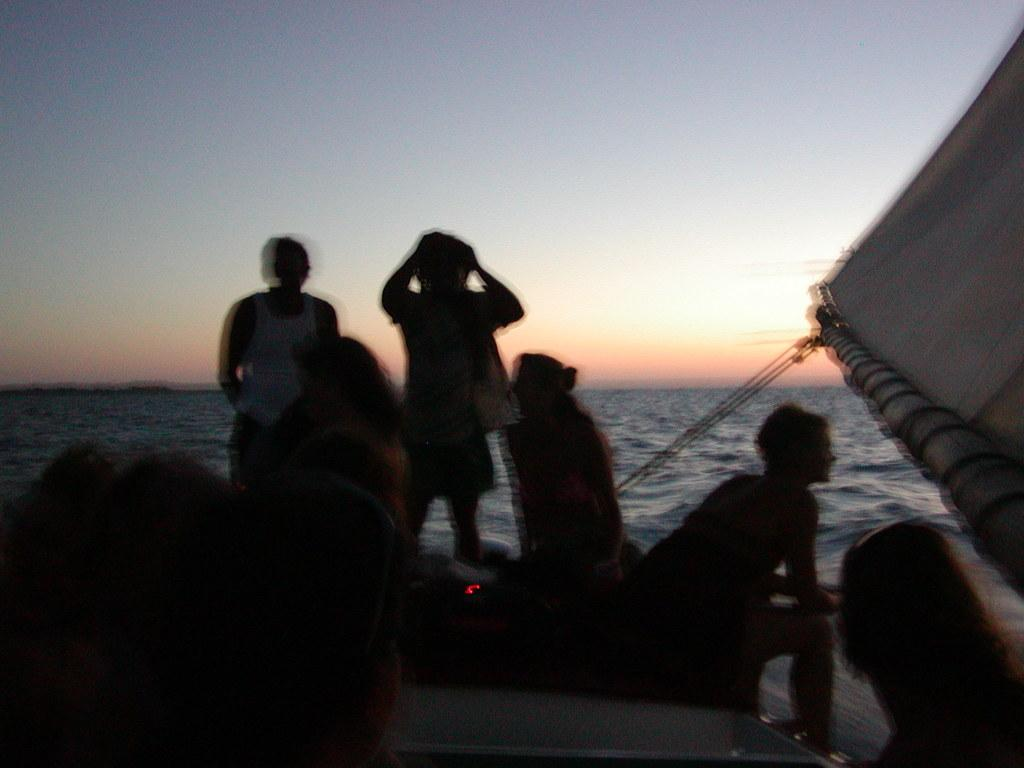How many people are in the image? There is a group of people in the image. What objects are present that might be used for tying or securing? There are ropes in the image. What is used to catch the wind in the image? There is a sail in the image. What type of natural environment is visible in the background of the image? The background of the image includes water. What is visible above the water in the image? The sky is visible in the background of the image. What type of metal is being used to support the mother in the image? There is no mother or metal present in the image. 